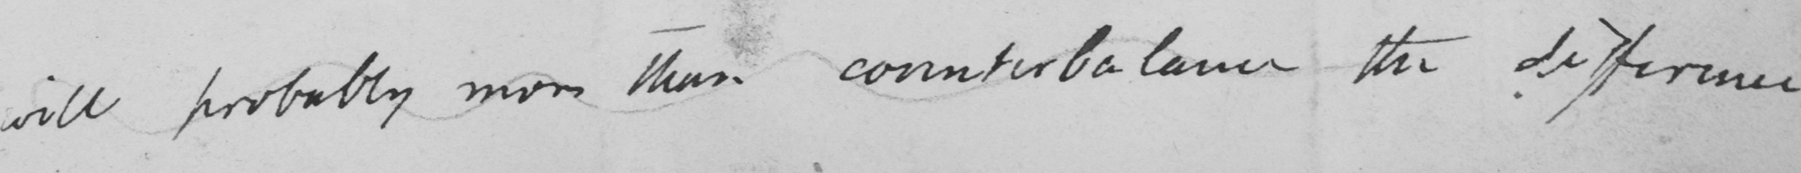What text is written in this handwritten line? will probably more than counterbalance the difference. 